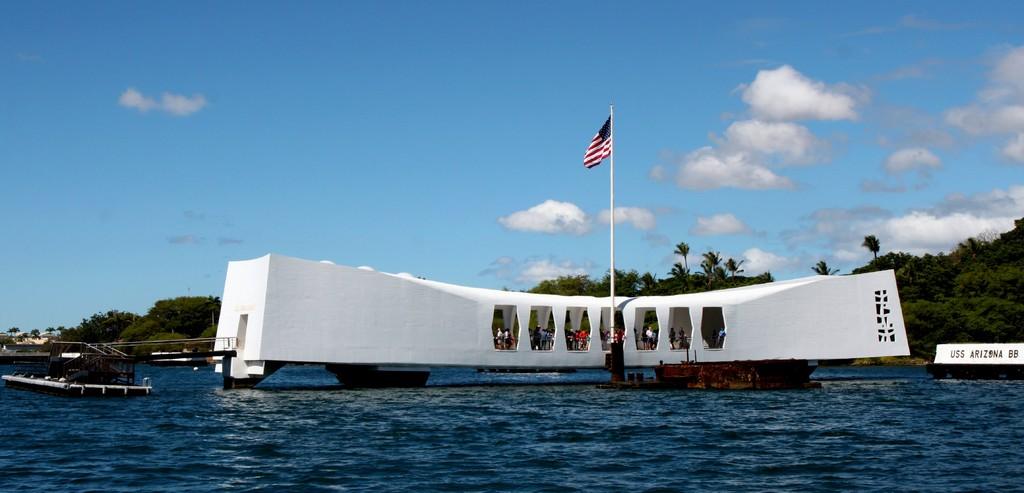What is the name of the ship on the right?
Offer a terse response. Uss arizona. What´s the flag on top?
Offer a terse response. Answering does not require reading text in the image. 